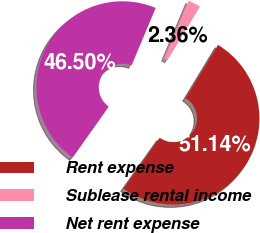<chart> <loc_0><loc_0><loc_500><loc_500><pie_chart><fcel>Rent expense<fcel>Sublease rental income<fcel>Net rent expense<nl><fcel>51.14%<fcel>2.36%<fcel>46.5%<nl></chart> 